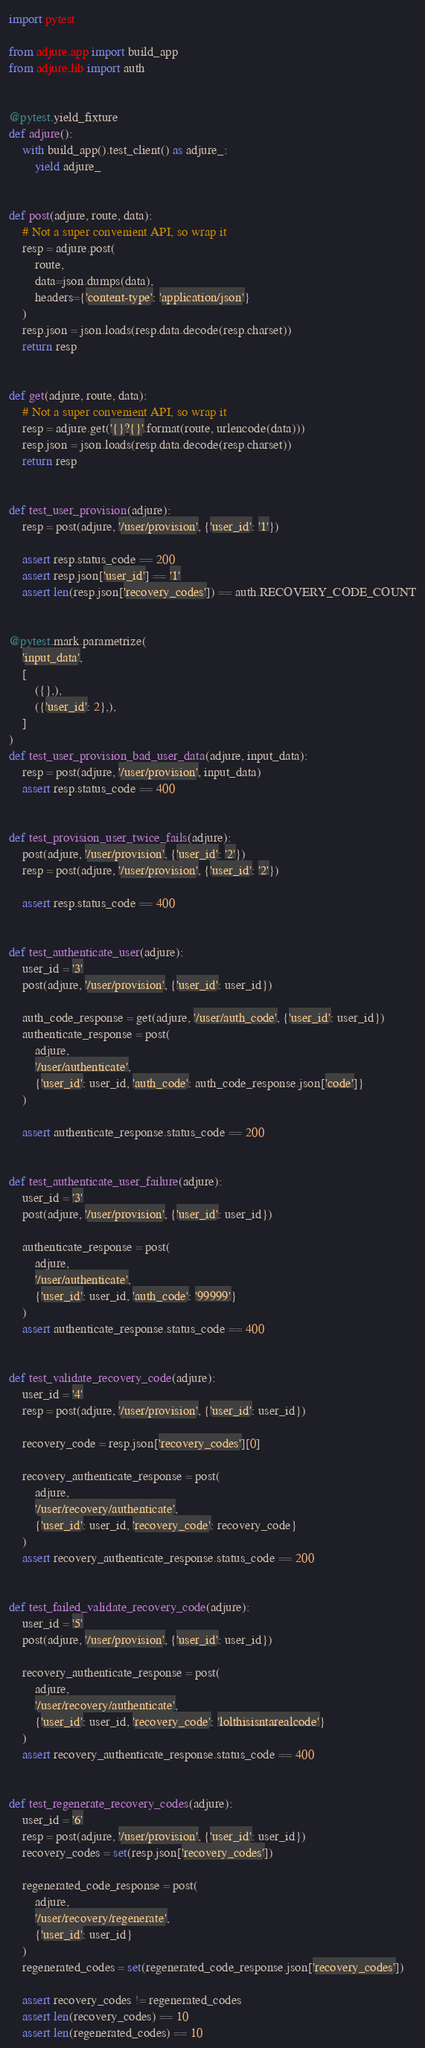<code> <loc_0><loc_0><loc_500><loc_500><_Python_>import pytest

from adjure.app import build_app
from adjure.lib import auth


@pytest.yield_fixture
def adjure():
    with build_app().test_client() as adjure_:
        yield adjure_


def post(adjure, route, data):
    # Not a super convenient API, so wrap it
    resp = adjure.post(
        route,
        data=json.dumps(data),
        headers={'content-type': 'application/json'}
    )
    resp.json = json.loads(resp.data.decode(resp.charset))
    return resp


def get(adjure, route, data):
    # Not a super convenient API, so wrap it
    resp = adjure.get('{}?{}'.format(route, urlencode(data)))
    resp.json = json.loads(resp.data.decode(resp.charset))
    return resp


def test_user_provision(adjure):
    resp = post(adjure, '/user/provision', {'user_id': '1'})

    assert resp.status_code == 200
    assert resp.json['user_id'] == '1'
    assert len(resp.json['recovery_codes']) == auth.RECOVERY_CODE_COUNT


@pytest.mark.parametrize(
    'input_data',
    [
        ({},),
        ({'user_id': 2},),
    ]
)
def test_user_provision_bad_user_data(adjure, input_data):
    resp = post(adjure, '/user/provision', input_data)
    assert resp.status_code == 400


def test_provision_user_twice_fails(adjure):
    post(adjure, '/user/provision', {'user_id': '2'})
    resp = post(adjure, '/user/provision', {'user_id': '2'})

    assert resp.status_code == 400


def test_authenticate_user(adjure):
    user_id = '3'
    post(adjure, '/user/provision', {'user_id': user_id})

    auth_code_response = get(adjure, '/user/auth_code', {'user_id': user_id})
    authenticate_response = post(
        adjure,
        '/user/authenticate',
        {'user_id': user_id, 'auth_code': auth_code_response.json['code']}
    )

    assert authenticate_response.status_code == 200


def test_authenticate_user_failure(adjure):
    user_id = '3'
    post(adjure, '/user/provision', {'user_id': user_id})

    authenticate_response = post(
        adjure,
        '/user/authenticate',
        {'user_id': user_id, 'auth_code': '99999'}
    )
    assert authenticate_response.status_code == 400


def test_validate_recovery_code(adjure):
    user_id = '4'
    resp = post(adjure, '/user/provision', {'user_id': user_id})

    recovery_code = resp.json['recovery_codes'][0]

    recovery_authenticate_response = post(
        adjure,
        '/user/recovery/authenticate',
        {'user_id': user_id, 'recovery_code': recovery_code}
    )
    assert recovery_authenticate_response.status_code == 200


def test_failed_validate_recovery_code(adjure):
    user_id = '5'
    post(adjure, '/user/provision', {'user_id': user_id})

    recovery_authenticate_response = post(
        adjure,
        '/user/recovery/authenticate',
        {'user_id': user_id, 'recovery_code': 'lolthisisntarealcode'}
    )
    assert recovery_authenticate_response.status_code == 400


def test_regenerate_recovery_codes(adjure):
    user_id = '6'
    resp = post(adjure, '/user/provision', {'user_id': user_id})
    recovery_codes = set(resp.json['recovery_codes'])

    regenerated_code_response = post(
        adjure,
        '/user/recovery/regenerate',
        {'user_id': user_id}
    )
    regenerated_codes = set(regenerated_code_response.json['recovery_codes'])

    assert recovery_codes != regenerated_codes
    assert len(recovery_codes) == 10
    assert len(regenerated_codes) == 10
</code> 